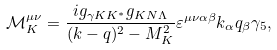Convert formula to latex. <formula><loc_0><loc_0><loc_500><loc_500>\mathcal { M } ^ { \mu \nu } _ { K } = \frac { i g _ { \gamma K K ^ { * } } g _ { K N \Lambda } } { ( k - q ) ^ { 2 } - M _ { K } ^ { 2 } } \varepsilon ^ { \mu \nu \alpha \beta } k _ { \alpha } q _ { \beta } \gamma _ { 5 } ,</formula> 